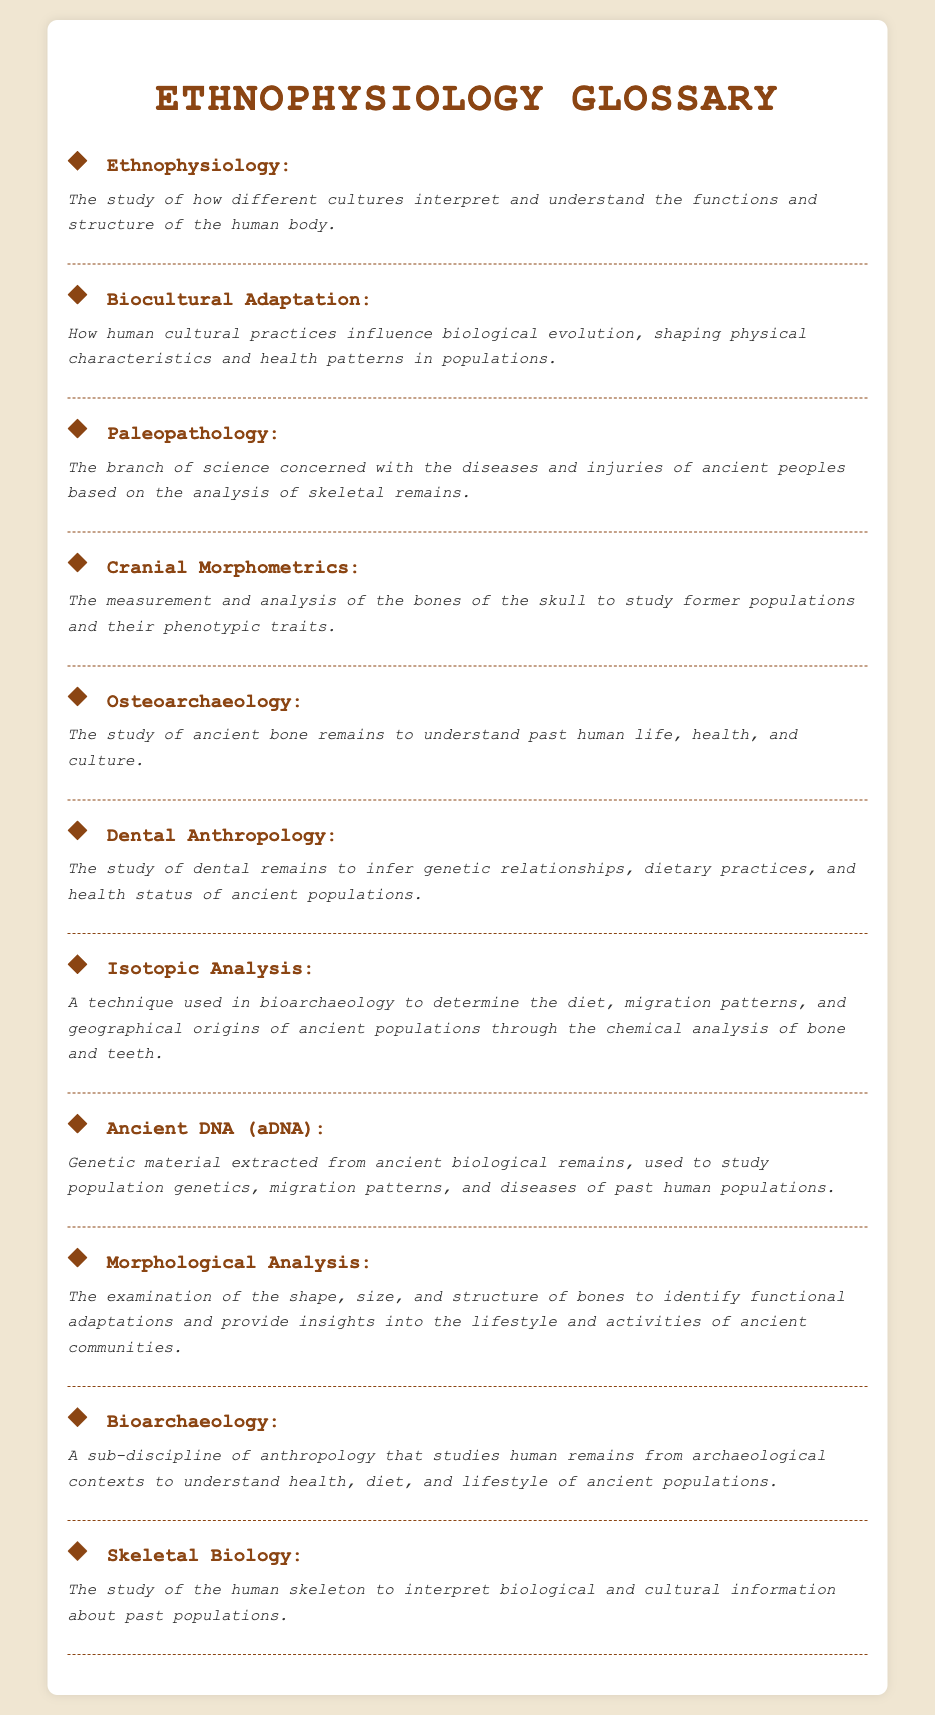What is the definition of Ethnophysiology? Ethnophysiology is defined in the document as the study of how different cultures interpret and understand the functions and structure of the human body.
Answer: The study of how different cultures interpret and understand the functions and structure of the human body What does Biocultural Adaptation refer to? The document explains that Biocultural Adaptation describes how human cultural practices influence biological evolution, shaping physical characteristics and health patterns in populations.
Answer: How human cultural practices influence biological evolution, shaping physical characteristics and health patterns in populations Which term is associated with the analysis of ancient diseases and injuries? The term associated with this analysis is Paleopathology, as specified in the glossary.
Answer: Paleopathology How many glossary items are listed in the document? The number of glossary items can be counted directly from the document; there are ten listed glossary items.
Answer: Ten What is the primary focus of Osteoarchaeology? The primary focus of Osteoarchaeology, according to the document, is the study of ancient bone remains to understand past human life, health, and culture.
Answer: The study of ancient bone remains to understand past human life, health, and culture What technique is mentioned for understanding diet and migration patterns? The document mentions Isotopic Analysis as a technique used in bioarchaeology to determine diet and migration patterns through chemical analysis.
Answer: Isotopic Analysis Which glossary term is specifically concerned with genetic material from ancient remains? The term related to genetic material from ancient remains is Ancient DNA (aDNA) as defined in the glossary.
Answer: Ancient DNA (aDNA) What does the term Morphological Analysis involve? The document states that Morphological Analysis involves the examination of shape, size, and structure of bones to identify functional adaptations.
Answer: The examination of the shape, size, and structure of bones to identify functional adaptations 